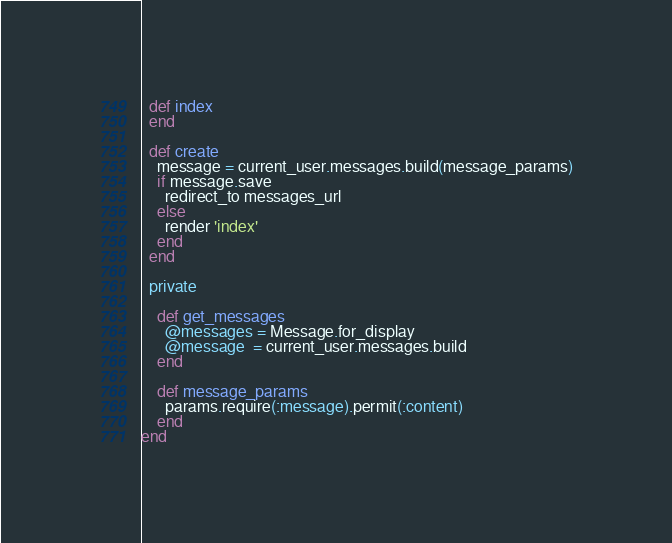Convert code to text. <code><loc_0><loc_0><loc_500><loc_500><_Ruby_>  def index
  end

  def create
    message = current_user.messages.build(message_params)
    if message.save
      redirect_to messages_url
    else
      render 'index'
    end
  end

  private

    def get_messages
      @messages = Message.for_display
      @message  = current_user.messages.build
    end

    def message_params
      params.require(:message).permit(:content)
    end
end
</code> 